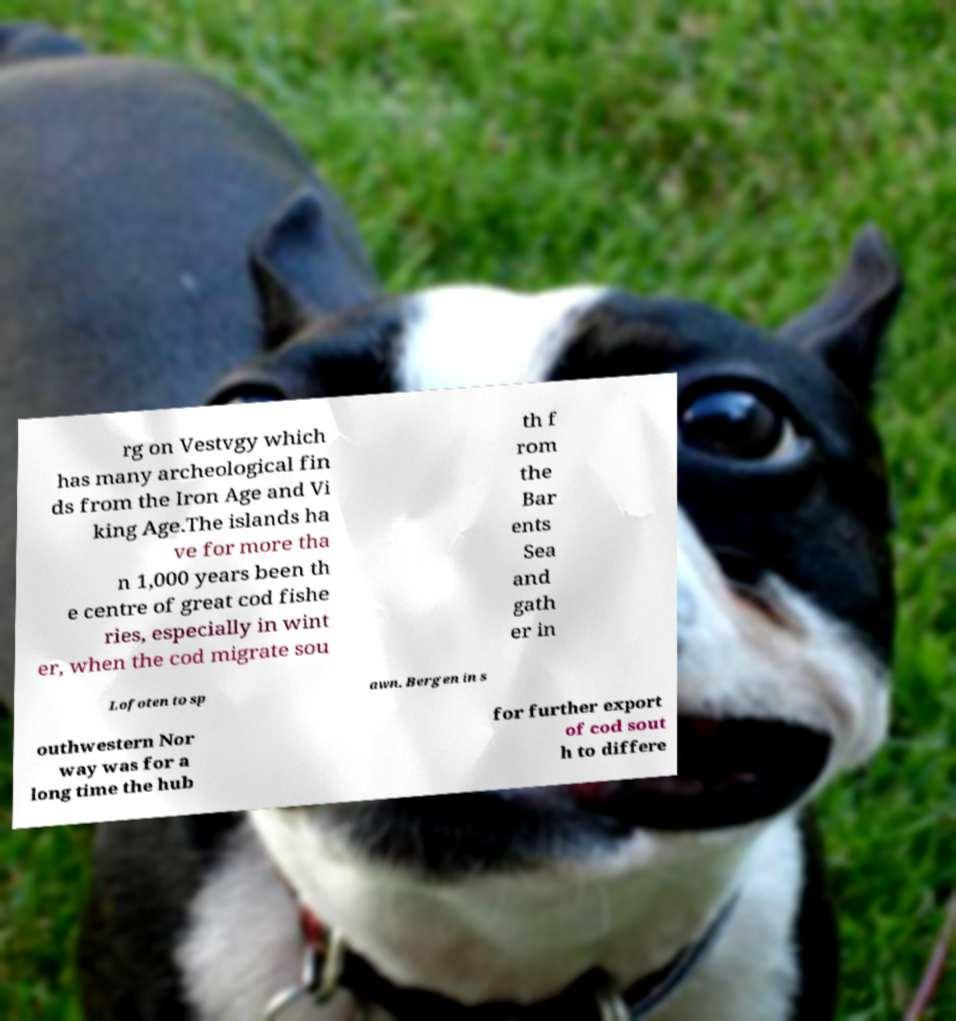For documentation purposes, I need the text within this image transcribed. Could you provide that? rg on Vestvgy which has many archeological fin ds from the Iron Age and Vi king Age.The islands ha ve for more tha n 1,000 years been th e centre of great cod fishe ries, especially in wint er, when the cod migrate sou th f rom the Bar ents Sea and gath er in Lofoten to sp awn. Bergen in s outhwestern Nor way was for a long time the hub for further export of cod sout h to differe 